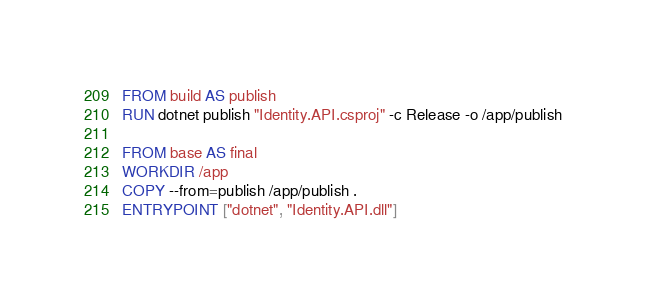<code> <loc_0><loc_0><loc_500><loc_500><_Dockerfile_>FROM build AS publish
RUN dotnet publish "Identity.API.csproj" -c Release -o /app/publish

FROM base AS final
WORKDIR /app
COPY --from=publish /app/publish .
ENTRYPOINT ["dotnet", "Identity.API.dll"]</code> 